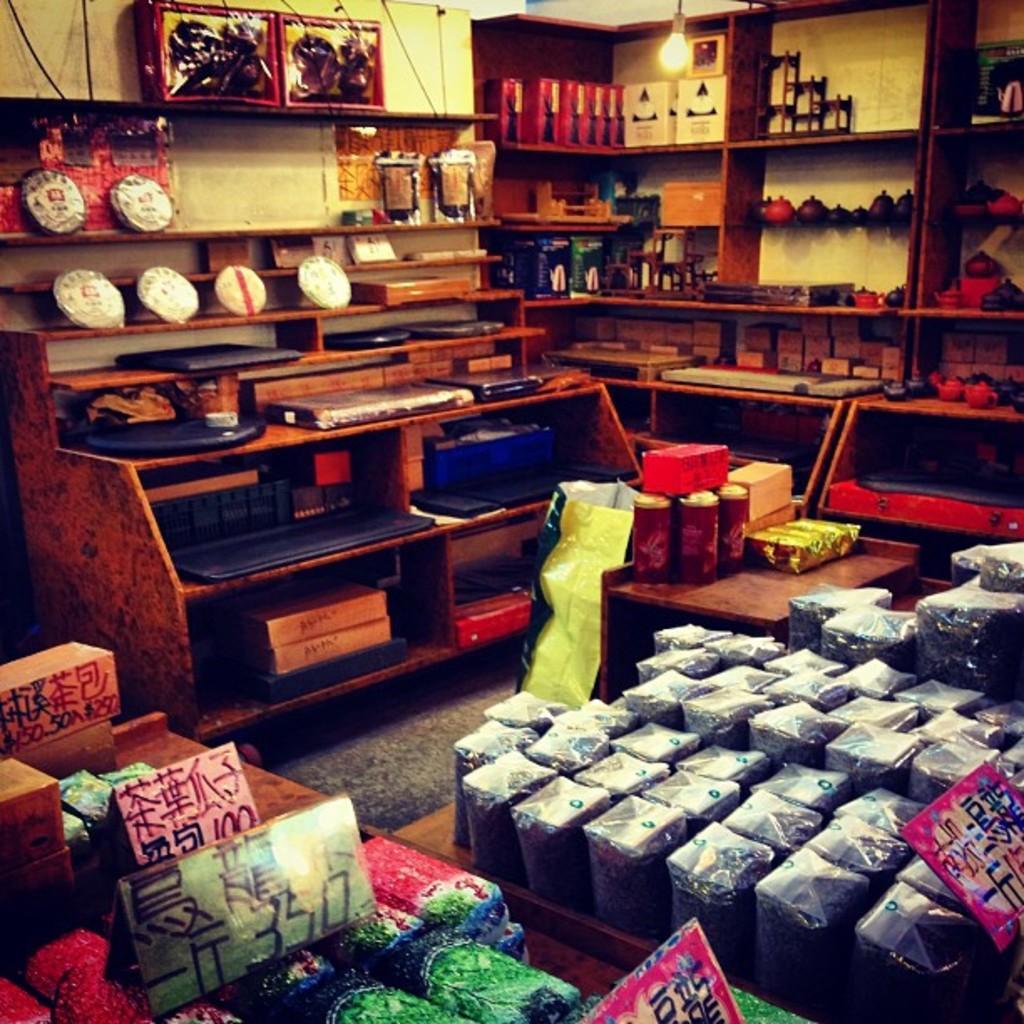How would you summarize this image in a sentence or two? In the picture we can see inside the house we can see some racks with some boxes and into the wall also we can see some racks with some things in it and to the ceiling there is a light and on the floor also we can see some boxes packed on the mat. 